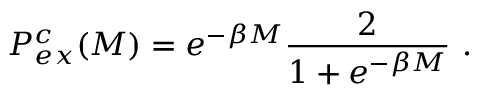Convert formula to latex. <formula><loc_0><loc_0><loc_500><loc_500>P _ { e x } ^ { c } ( M ) = e ^ { - \beta M } \frac { 2 } { 1 + e ^ { - \beta M } } \, .</formula> 